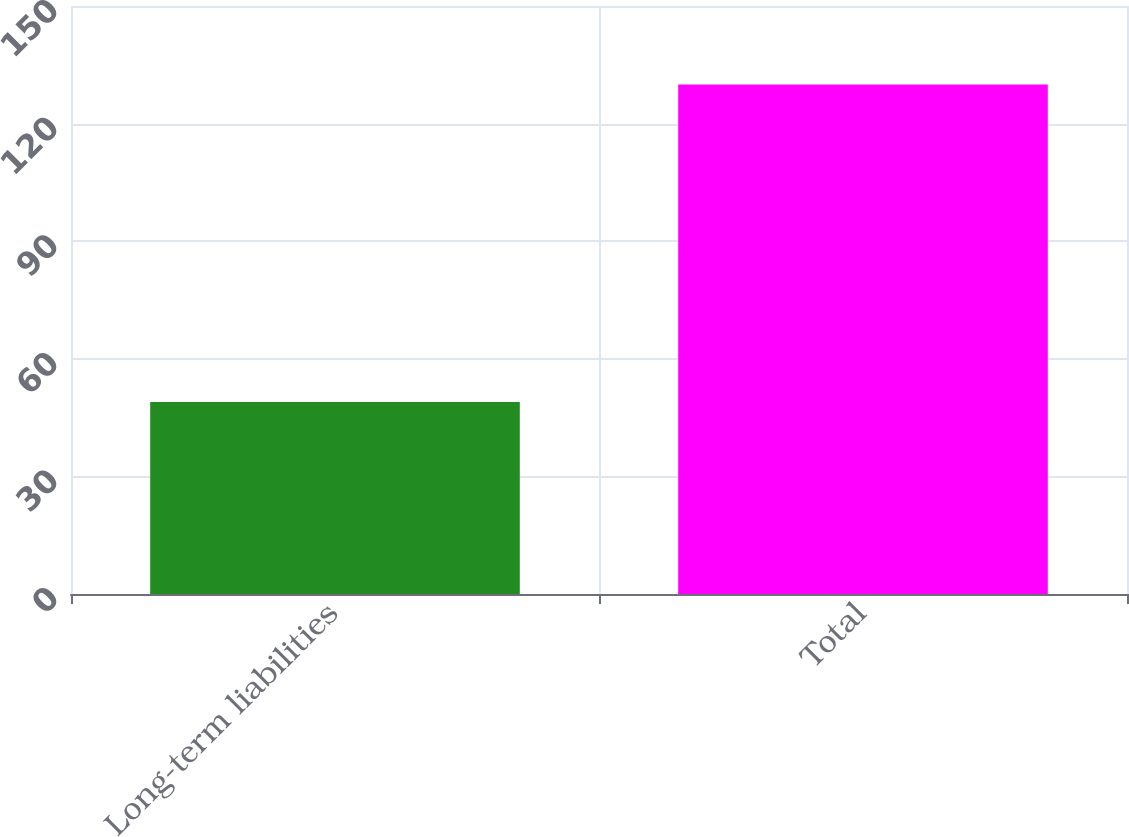Convert chart. <chart><loc_0><loc_0><loc_500><loc_500><bar_chart><fcel>Long-term liabilities<fcel>Total<nl><fcel>49<fcel>130<nl></chart> 